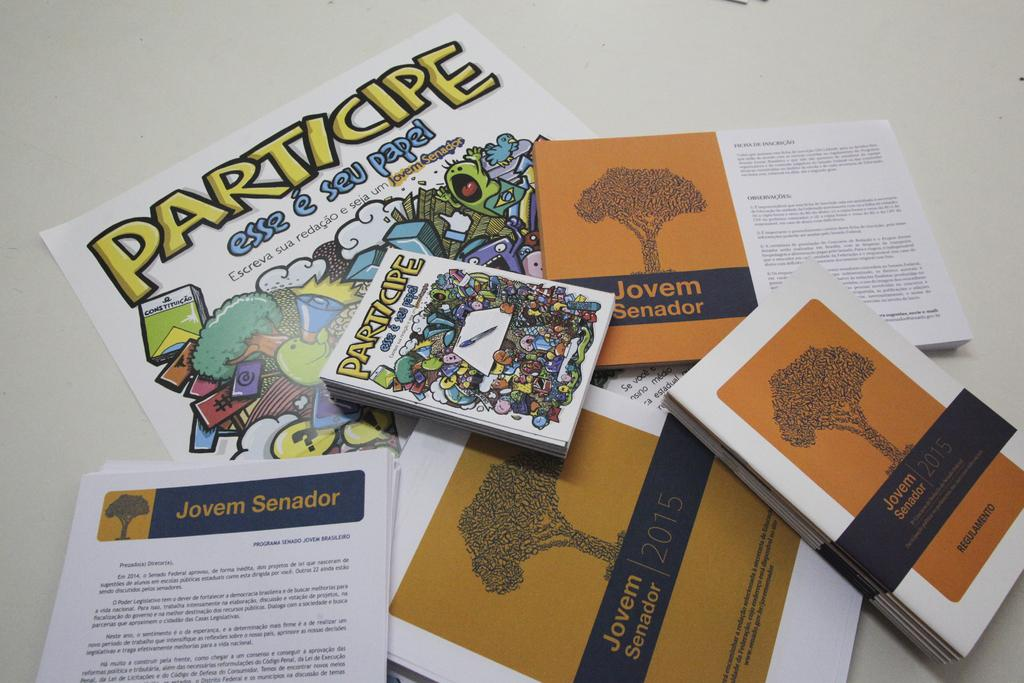Provide a one-sentence caption for the provided image. Several blue and orange papers and books promote Jovem Senador. 